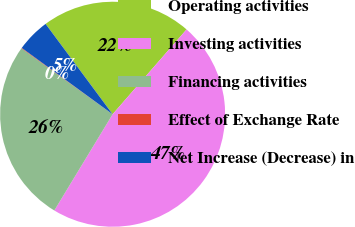<chart> <loc_0><loc_0><loc_500><loc_500><pie_chart><fcel>Operating activities<fcel>Investing activities<fcel>Financing activities<fcel>Effect of Exchange Rate<fcel>Net Increase (Decrease) in<nl><fcel>21.57%<fcel>47.26%<fcel>26.29%<fcel>0.08%<fcel>4.8%<nl></chart> 